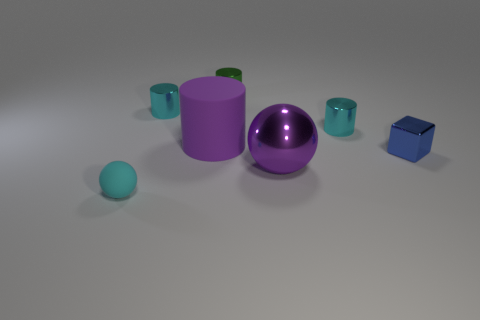Can you describe the shapes of the objects present? Certainly! There's a tall purple cylinder, a large purple sphere, and four smaller cylindrical cups that appear to be in shades of teal or cyan. Additionally, there's a small blue cube to the right. 